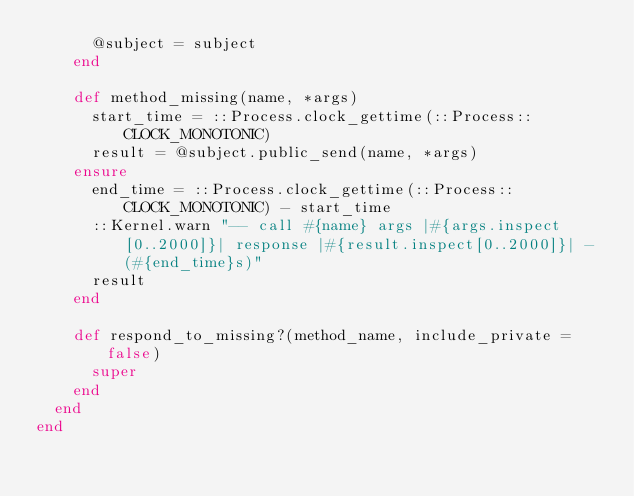Convert code to text. <code><loc_0><loc_0><loc_500><loc_500><_Ruby_>      @subject = subject
    end

    def method_missing(name, *args)
      start_time = ::Process.clock_gettime(::Process::CLOCK_MONOTONIC)
      result = @subject.public_send(name, *args)
    ensure
      end_time = ::Process.clock_gettime(::Process::CLOCK_MONOTONIC) - start_time
      ::Kernel.warn "-- call #{name} args |#{args.inspect[0..2000]}| response |#{result.inspect[0..2000]}| - (#{end_time}s)"
      result
    end

    def respond_to_missing?(method_name, include_private = false)
      super
    end
  end
end
</code> 